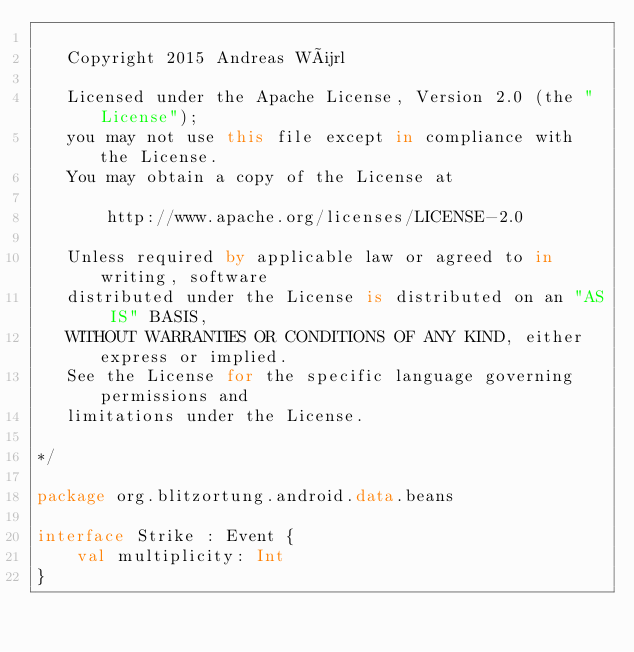Convert code to text. <code><loc_0><loc_0><loc_500><loc_500><_Kotlin_>
   Copyright 2015 Andreas Würl

   Licensed under the Apache License, Version 2.0 (the "License");
   you may not use this file except in compliance with the License.
   You may obtain a copy of the License at

       http://www.apache.org/licenses/LICENSE-2.0

   Unless required by applicable law or agreed to in writing, software
   distributed under the License is distributed on an "AS IS" BASIS,
   WITHOUT WARRANTIES OR CONDITIONS OF ANY KIND, either express or implied.
   See the License for the specific language governing permissions and
   limitations under the License.

*/

package org.blitzortung.android.data.beans

interface Strike : Event {
    val multiplicity: Int
}
</code> 